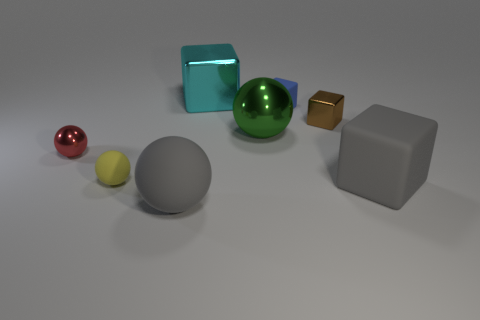Subtract all brown blocks. How many blocks are left? 3 Add 2 large gray metal blocks. How many objects exist? 10 Subtract all cyan cubes. How many cubes are left? 3 Subtract 3 spheres. How many spheres are left? 1 Add 8 red objects. How many red objects are left? 9 Add 7 small red shiny objects. How many small red shiny objects exist? 8 Subtract 0 cyan spheres. How many objects are left? 8 Subtract all red balls. Subtract all brown cylinders. How many balls are left? 3 Subtract all gray rubber objects. Subtract all small matte spheres. How many objects are left? 5 